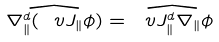<formula> <loc_0><loc_0><loc_500><loc_500>\widehat { \nabla _ { \| } ^ { d } ( \ v J _ { \| } \phi ) } = \widehat { \ v J _ { \| } ^ { d } \nabla _ { \| } \phi }</formula> 